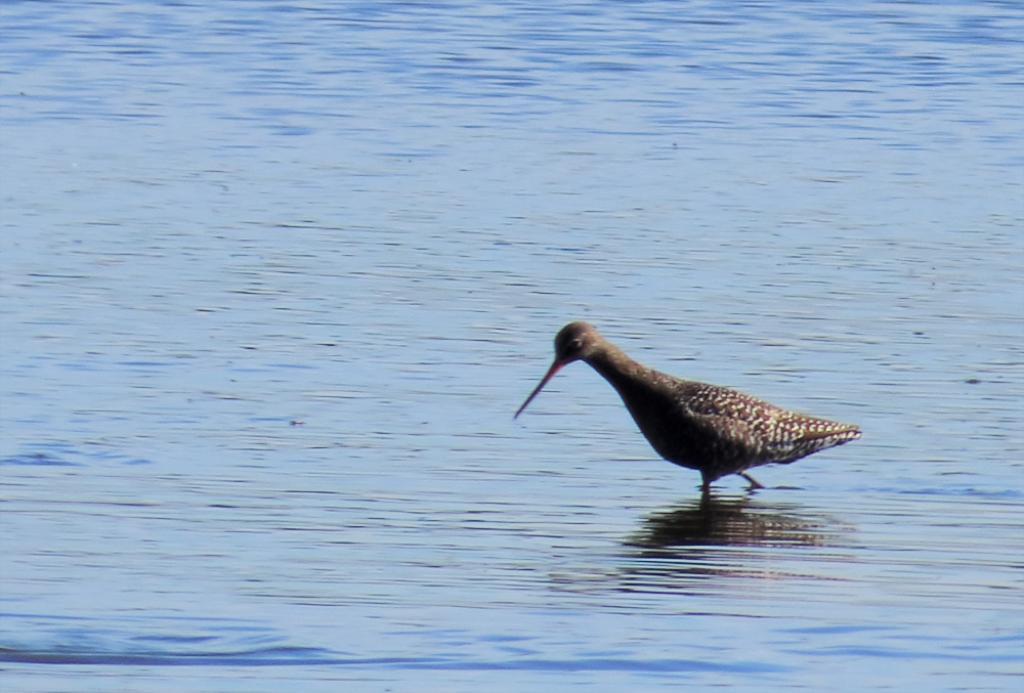Describe this image in one or two sentences. In this image on the water body a bird is walking. 